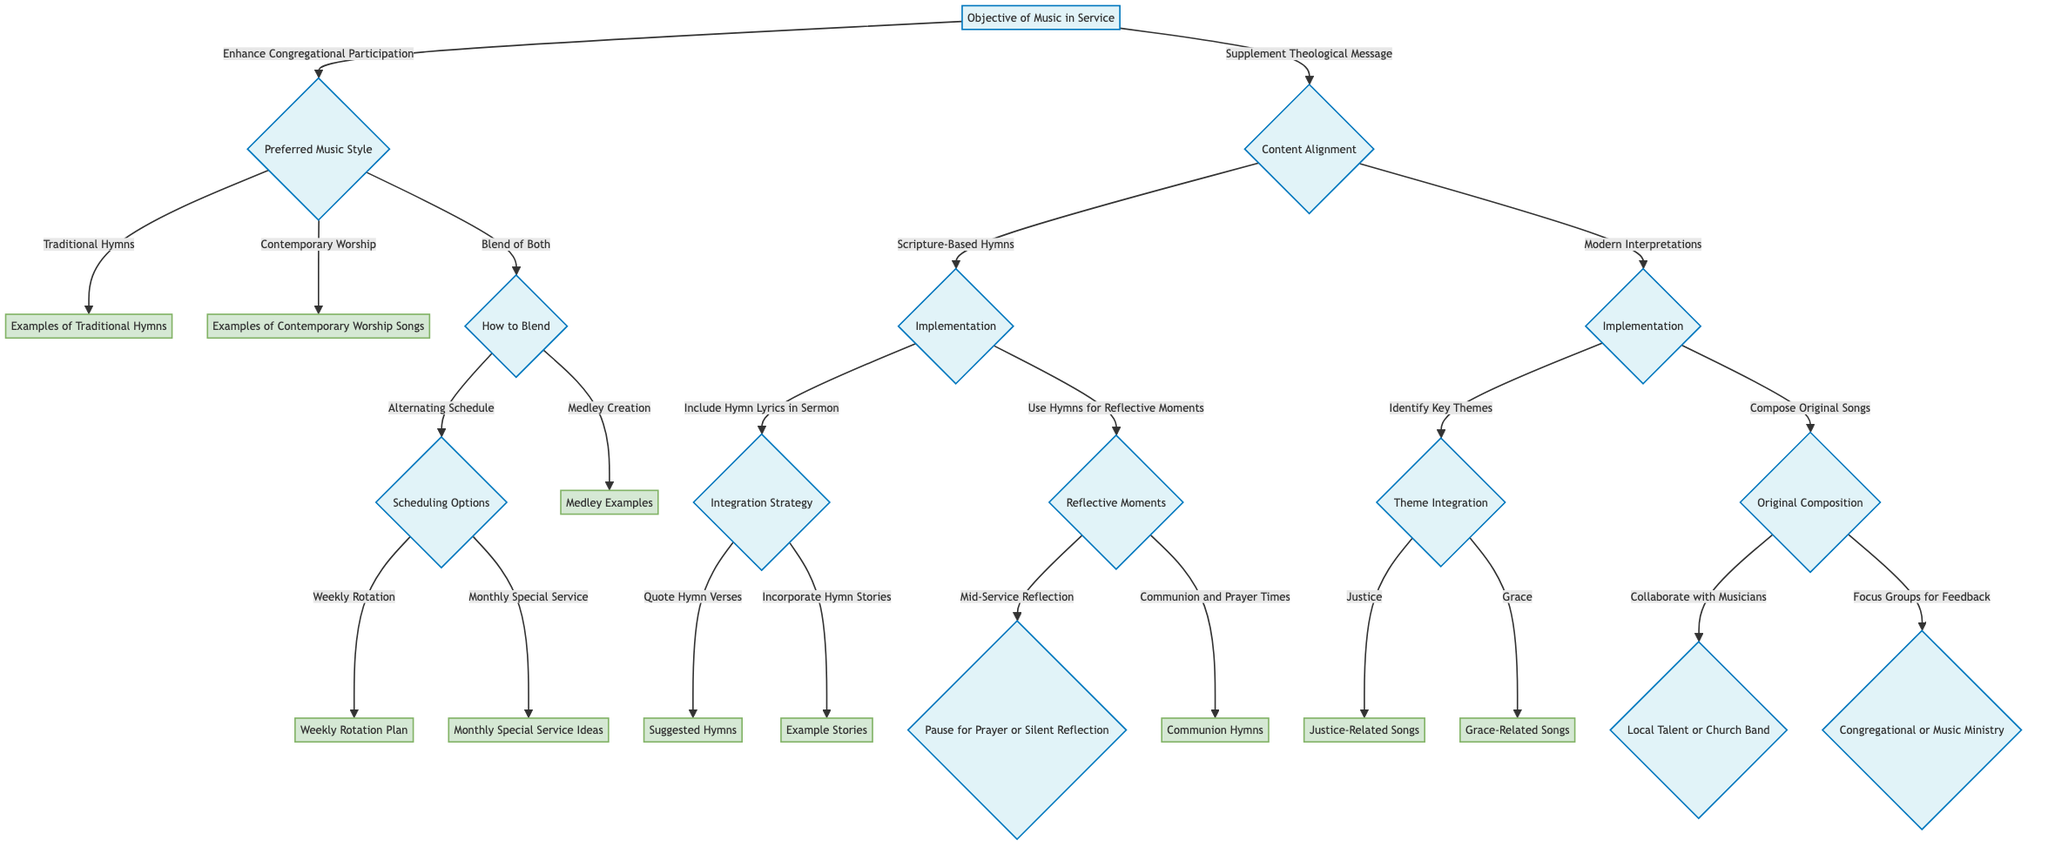What are the two main objectives of music in the service? The decision tree starts with the node "Objective of Music in Service," which presents two choices: "Enhance Congregational Participation" and "Supplement Theological Message." Since these options reflect the primary goals outlined, they are the two main objectives.
Answer: Enhance Congregational Participation, Supplement Theological Message What is the next step if the objective is to enhance congregational participation? When you choose "Enhance Congregational Participation," the decision tree leads to the next node "Preferred Music Style," which offers three music style options. Therefore, this is the next step in the process.
Answer: Preferred Music Style How many nodes lead from the "Content Alignment" node? From the "Content Alignment" node, there are two specific pathways: "Scripture-Based Hymns" and "Modern Interpretations." Thus, there are two nodes leading from this point.
Answer: 2 What are the two options to blend traditional hymns and contemporary music? Looking at the decision tree, the "How to Blend" node gives two distinct options: "Alternating Schedule" and "Medley Creation." These are the two methods outlined for blending the music styles.
Answer: Alternating Schedule, Medley Creation What are the examples of communal hymns for communion times? The decision tree indicates that under the "Communion and Prayer Times" node, you would find "Communion Hymns" specifically. The examples listed there include "Let Us Break Bread Together" and "The Old Rugged Cross." Therefore, these hymns are suggested for communion.
Answer: Let Us Break Bread Together, The Old Rugged Cross What are two themes mentioned for the integration of modern interpretations in music? The node "Theme Integration," which follows the "Identify Key Themes" node from "Modern Interpretations," offers two options— "Justice" and "Grace." Therefore, these are the themes that can be integrated within the context of contemporary music.
Answer: Justice, Grace How can hymns be integrated into sermons? At the "Integration Strategy" node after choosing "Include Hymn Lyrics in Sermon," there are two specific strategies: "Quote Hymn Verses" and "Incorporate Hymn Stories." Both strategies explain how hymns can effectively be integrated into sermons.
Answer: Quote Hymn Verses, Incorporate Hymn Stories What scheduling options are available to blend both music styles? The "How to Blend" node indicates that when you decide to blend both music styles, you can choose either "Alternating Schedule" or "Medley Creation." Once you select "Alternating Schedule," it branches into "Scheduling Options," which provides options for how to manage this blending in the worship service.
Answer: Weekly Rotation, Monthly Special Service What type of feedback channels might be used for focus groups in song composition? Within the decision tree, the "Focus Groups for Feedback" node indicates that feedback channels could include "Congregational Involvement" which then specifies feedback types like "Surveys and Suggestions" such as "Online Surveys" and "Suggestion Boxes." Therefore, this shows how feedback can be gathered from the congregation.
Answer: Online Surveys, Suggestion Boxes 